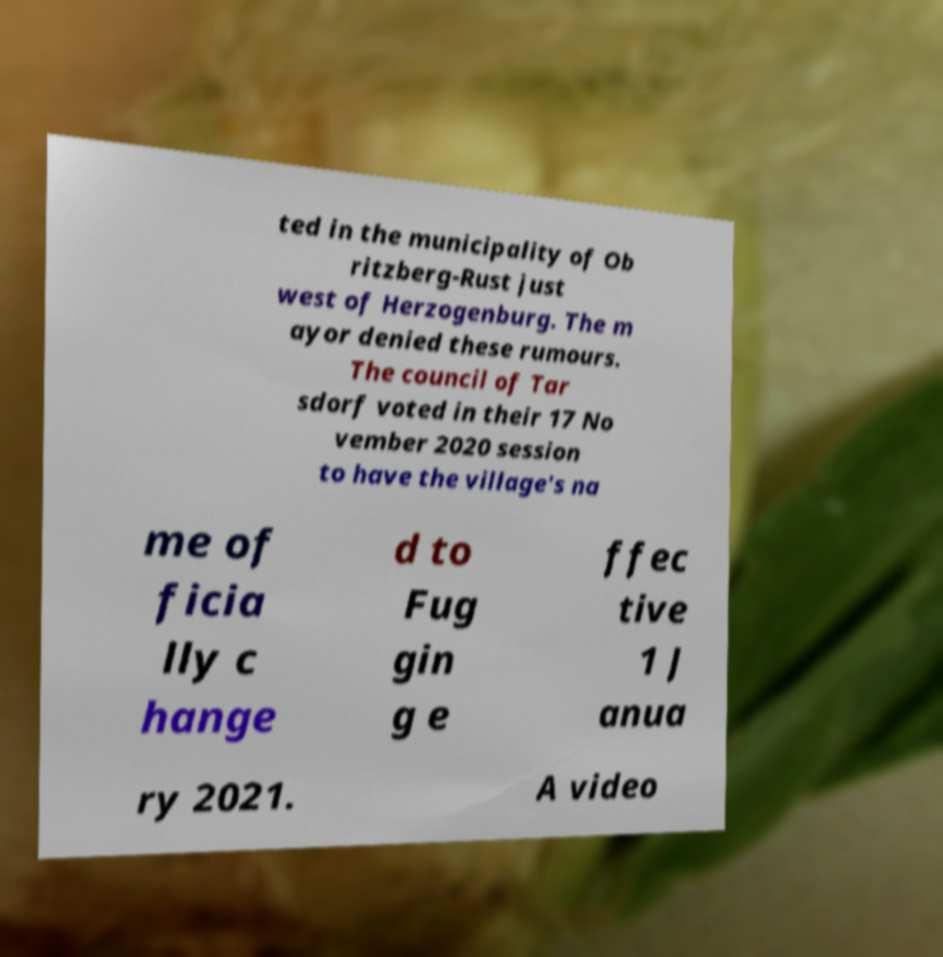Please read and relay the text visible in this image. What does it say? ted in the municipality of Ob ritzberg-Rust just west of Herzogenburg. The m ayor denied these rumours. The council of Tar sdorf voted in their 17 No vember 2020 session to have the village's na me of ficia lly c hange d to Fug gin g e ffec tive 1 J anua ry 2021. A video 